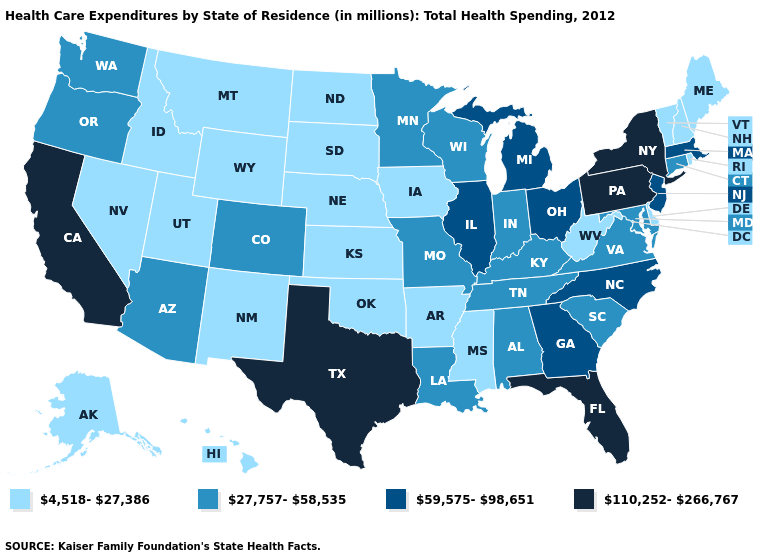What is the value of Washington?
Give a very brief answer. 27,757-58,535. Does Massachusetts have a lower value than California?
Concise answer only. Yes. What is the value of Oklahoma?
Quick response, please. 4,518-27,386. What is the highest value in the USA?
Give a very brief answer. 110,252-266,767. Does the map have missing data?
Answer briefly. No. What is the value of Pennsylvania?
Concise answer only. 110,252-266,767. Which states have the lowest value in the West?
Keep it brief. Alaska, Hawaii, Idaho, Montana, Nevada, New Mexico, Utah, Wyoming. What is the value of Alabama?
Give a very brief answer. 27,757-58,535. Does Texas have the same value as North Carolina?
Answer briefly. No. Name the states that have a value in the range 110,252-266,767?
Concise answer only. California, Florida, New York, Pennsylvania, Texas. Does New Hampshire have the lowest value in the Northeast?
Give a very brief answer. Yes. What is the lowest value in the MidWest?
Concise answer only. 4,518-27,386. Among the states that border Mississippi , does Alabama have the highest value?
Give a very brief answer. Yes. Among the states that border Nebraska , which have the highest value?
Be succinct. Colorado, Missouri. What is the value of Missouri?
Answer briefly. 27,757-58,535. 